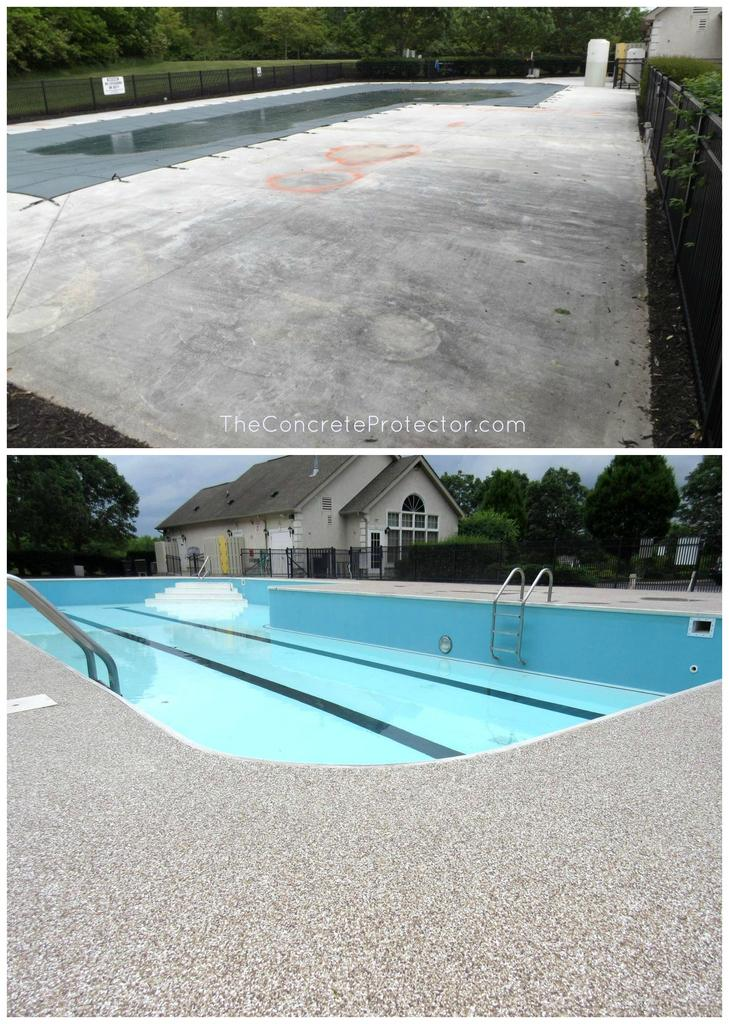What type of water feature is present in the image? There is a swimming pool in the image. What type of structure is visible in the image? There is a house in the image. What type of barrier is present in the image? There is a fence in the image. What type of vegetation is present in the image? There are trees in the image. What type of text is present in the image? There is text in the image. What part of the natural environment is visible in the image? The sky is visible in the image. How was the image created or modified? The image appears to be an edited photo. What is the price of the sea visible in the image? There is no sea present in the image; it features a swimming pool. What type of bottle is shown in the image? There is no bottle present in the image. 